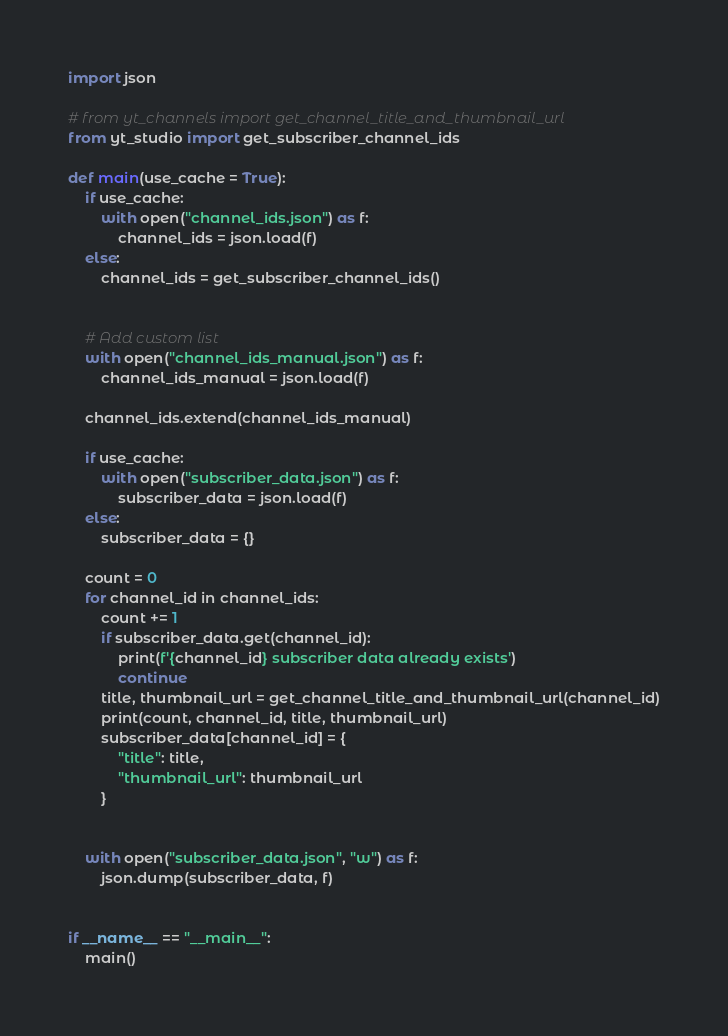<code> <loc_0><loc_0><loc_500><loc_500><_Python_>import json 

# from yt_channels import get_channel_title_and_thumbnail_url
from yt_studio import get_subscriber_channel_ids

def main(use_cache = True):
    if use_cache:
        with open("channel_ids.json") as f:
            channel_ids = json.load(f)        
    else:
        channel_ids = get_subscriber_channel_ids()


    # Add custom list
    with open("channel_ids_manual.json") as f:
        channel_ids_manual = json.load(f)

    channel_ids.extend(channel_ids_manual)

    if use_cache:
        with open("subscriber_data.json") as f:
            subscriber_data = json.load(f)
    else:
        subscriber_data = {}

    count = 0
    for channel_id in channel_ids:
        count += 1
        if subscriber_data.get(channel_id):
            print(f'{channel_id} subscriber data already exists')
            continue
        title, thumbnail_url = get_channel_title_and_thumbnail_url(channel_id)
        print(count, channel_id, title, thumbnail_url)
        subscriber_data[channel_id] = {
            "title": title,
            "thumbnail_url": thumbnail_url
        }
        

    with open("subscriber_data.json", "w") as f:
        json.dump(subscriber_data, f)


if __name__ == "__main__":
    main()</code> 